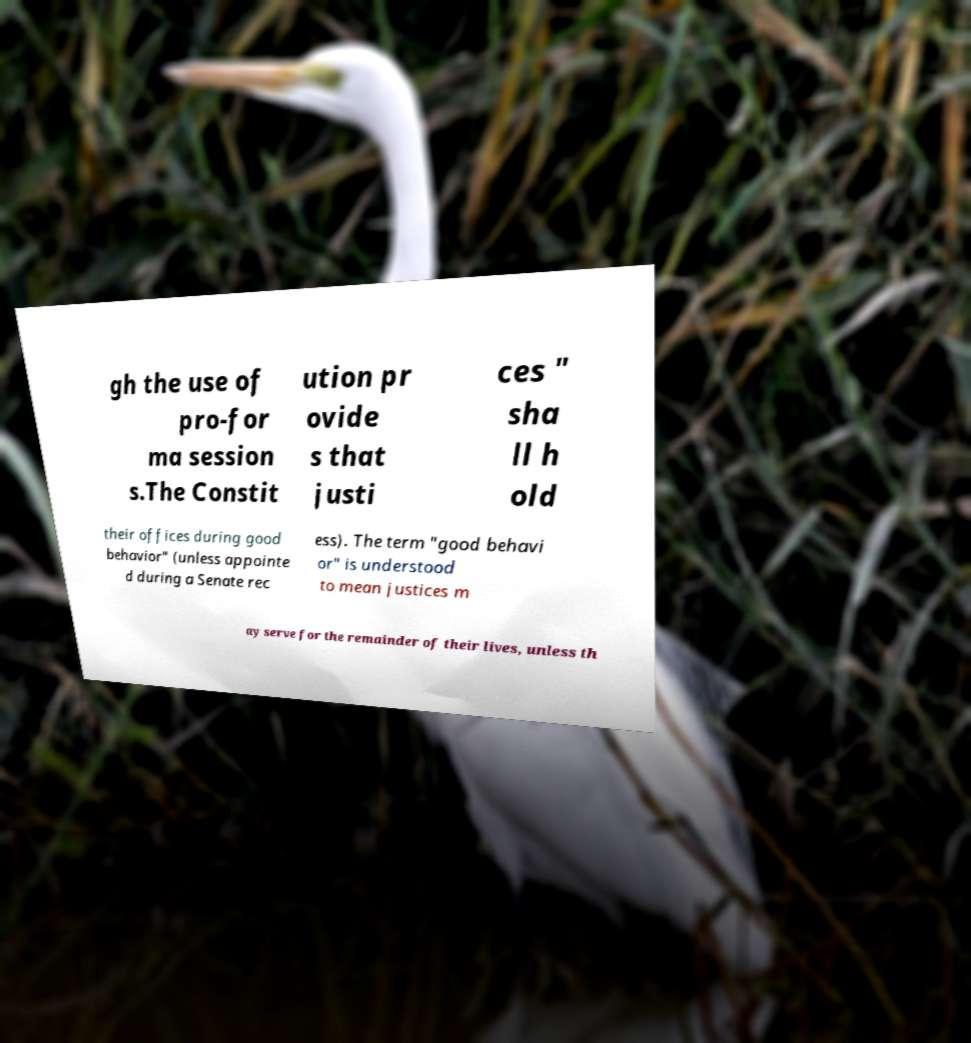Could you extract and type out the text from this image? gh the use of pro-for ma session s.The Constit ution pr ovide s that justi ces " sha ll h old their offices during good behavior" (unless appointe d during a Senate rec ess). The term "good behavi or" is understood to mean justices m ay serve for the remainder of their lives, unless th 